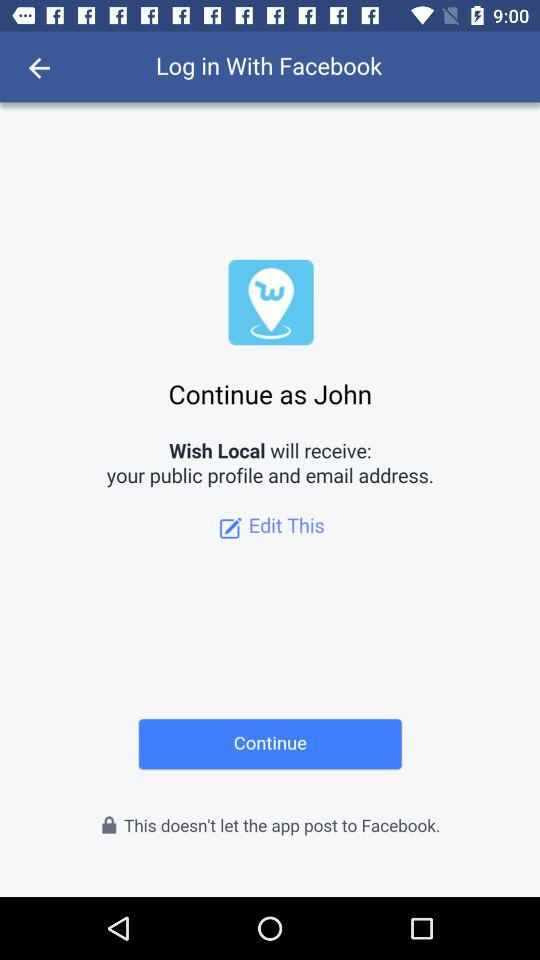What application is asking for permission? The application asking for permission is "Wish Local". 